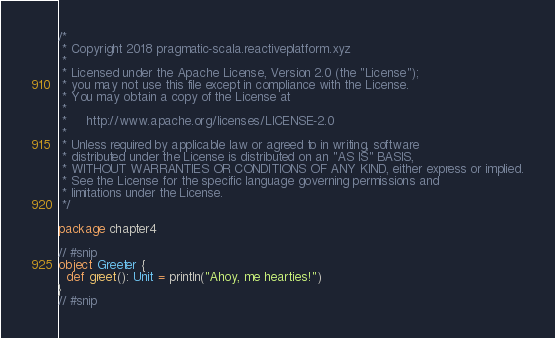<code> <loc_0><loc_0><loc_500><loc_500><_Scala_>/*
 * Copyright 2018 pragmatic-scala.reactiveplatform.xyz
 *
 * Licensed under the Apache License, Version 2.0 (the "License");
 * you may not use this file except in compliance with the License.
 * You may obtain a copy of the License at
 *
 *     http://www.apache.org/licenses/LICENSE-2.0
 *
 * Unless required by applicable law or agreed to in writing, software
 * distributed under the License is distributed on an "AS IS" BASIS,
 * WITHOUT WARRANTIES OR CONDITIONS OF ANY KIND, either express or implied.
 * See the License for the specific language governing permissions and
 * limitations under the License.
 */

package chapter4

// #snip
object Greeter {
  def greet(): Unit = println("Ahoy, me hearties!")
}
// #snip

</code> 